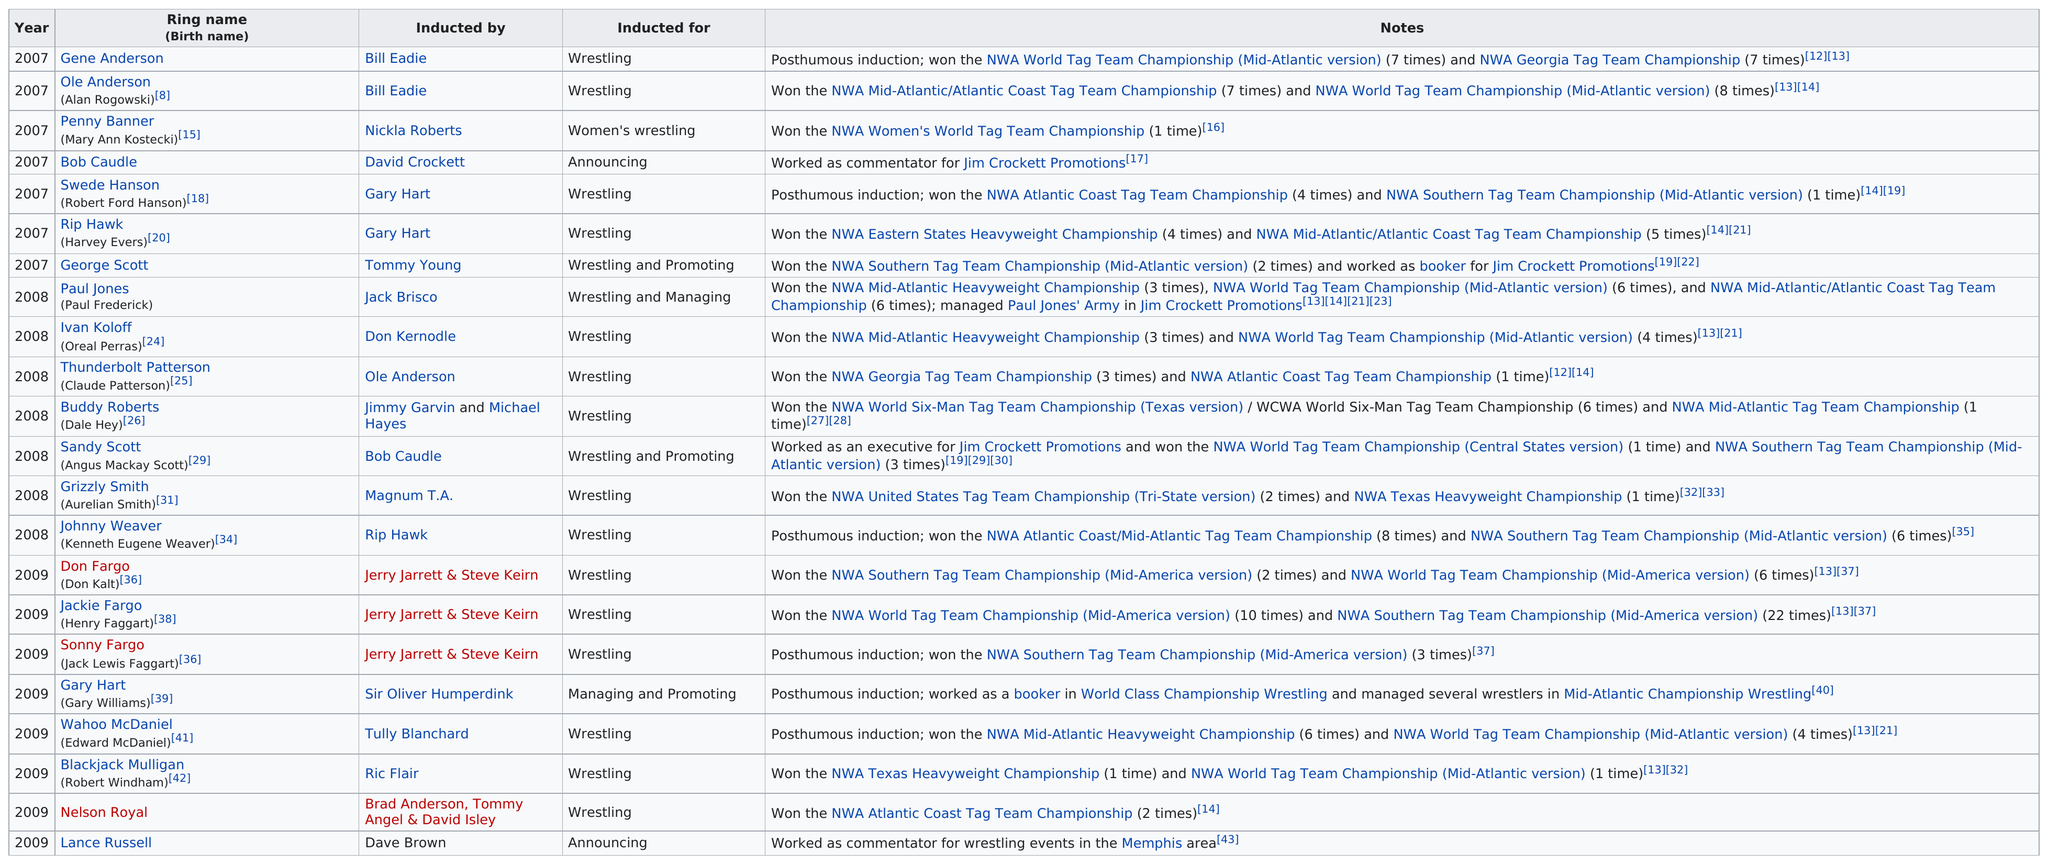Draw attention to some important aspects in this diagram. Bob Caudle, an announcer, was accompanied by Lance Russell, who was also an announcer. Wahoo McDaniel holds the record for the most successful reigns as the NWA Mid-Atlantic Heavyweight Champion, having won the title a staggering six times. My name is Dale Hey, but I am also known as Grizzly Smith or Buddy Roberts. My friends and colleagues call me Buddy Roberts. There were 2 members who were inducted for the purpose of announcing. Gene Anderson, an inductee who was not living at the time of induction, is a notable example. 